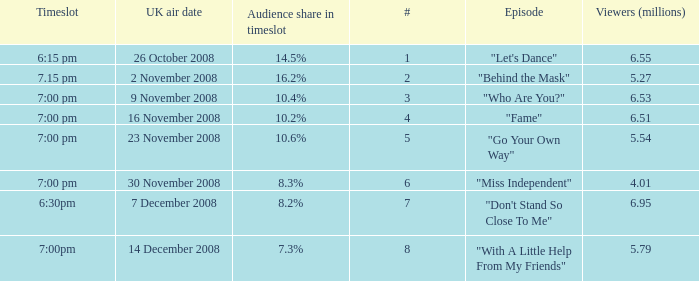Write the full table. {'header': ['Timeslot', 'UK air date', 'Audience share in timeslot', '#', 'Episode', 'Viewers (millions)'], 'rows': [['6:15 pm', '26 October 2008', '14.5%', '1', '"Let\'s Dance"', '6.55'], ['7.15 pm', '2 November 2008', '16.2%', '2', '"Behind the Mask"', '5.27'], ['7:00 pm', '9 November 2008', '10.4%', '3', '"Who Are You?"', '6.53'], ['7:00 pm', '16 November 2008', '10.2%', '4', '"Fame"', '6.51'], ['7:00 pm', '23 November 2008', '10.6%', '5', '"Go Your Own Way"', '5.54'], ['7:00 pm', '30 November 2008', '8.3%', '6', '"Miss Independent"', '4.01'], ['6:30pm', '7 December 2008', '8.2%', '7', '"Don\'t Stand So Close To Me"', '6.95'], ['7:00pm', '14 December 2008', '7.3%', '8', '"With A Little Help From My Friends"', '5.79']]} Name the timeslot for 6.51 viewers 7:00 pm. 